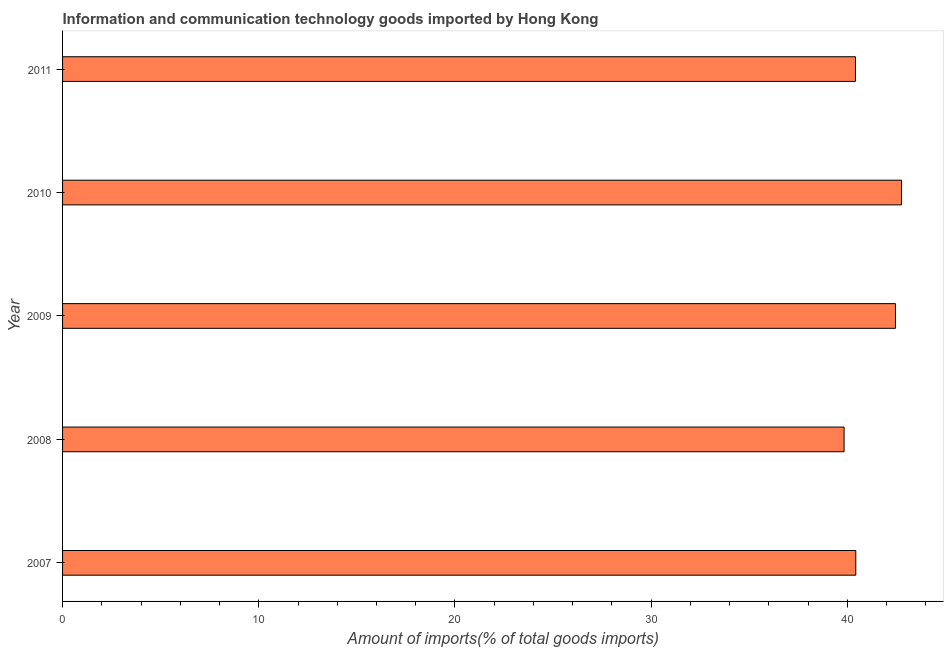Does the graph contain any zero values?
Give a very brief answer. No. What is the title of the graph?
Your answer should be very brief. Information and communication technology goods imported by Hong Kong. What is the label or title of the X-axis?
Your response must be concise. Amount of imports(% of total goods imports). What is the label or title of the Y-axis?
Provide a succinct answer. Year. What is the amount of ict goods imports in 2009?
Provide a short and direct response. 42.45. Across all years, what is the maximum amount of ict goods imports?
Provide a short and direct response. 42.76. Across all years, what is the minimum amount of ict goods imports?
Make the answer very short. 39.83. In which year was the amount of ict goods imports maximum?
Give a very brief answer. 2010. What is the sum of the amount of ict goods imports?
Give a very brief answer. 205.89. What is the difference between the amount of ict goods imports in 2007 and 2009?
Provide a succinct answer. -2.02. What is the average amount of ict goods imports per year?
Provide a short and direct response. 41.18. What is the median amount of ict goods imports?
Provide a short and direct response. 40.43. Is the amount of ict goods imports in 2008 less than that in 2011?
Give a very brief answer. Yes. What is the difference between the highest and the second highest amount of ict goods imports?
Give a very brief answer. 0.31. Is the sum of the amount of ict goods imports in 2007 and 2008 greater than the maximum amount of ict goods imports across all years?
Keep it short and to the point. Yes. What is the difference between the highest and the lowest amount of ict goods imports?
Keep it short and to the point. 2.93. In how many years, is the amount of ict goods imports greater than the average amount of ict goods imports taken over all years?
Your answer should be very brief. 2. How many bars are there?
Your answer should be compact. 5. Are all the bars in the graph horizontal?
Your answer should be very brief. Yes. How many years are there in the graph?
Your response must be concise. 5. What is the difference between two consecutive major ticks on the X-axis?
Your answer should be very brief. 10. Are the values on the major ticks of X-axis written in scientific E-notation?
Your answer should be very brief. No. What is the Amount of imports(% of total goods imports) in 2007?
Give a very brief answer. 40.43. What is the Amount of imports(% of total goods imports) of 2008?
Keep it short and to the point. 39.83. What is the Amount of imports(% of total goods imports) of 2009?
Keep it short and to the point. 42.45. What is the Amount of imports(% of total goods imports) of 2010?
Your answer should be compact. 42.76. What is the Amount of imports(% of total goods imports) in 2011?
Ensure brevity in your answer.  40.41. What is the difference between the Amount of imports(% of total goods imports) in 2007 and 2008?
Your answer should be very brief. 0.6. What is the difference between the Amount of imports(% of total goods imports) in 2007 and 2009?
Your answer should be compact. -2.02. What is the difference between the Amount of imports(% of total goods imports) in 2007 and 2010?
Give a very brief answer. -2.33. What is the difference between the Amount of imports(% of total goods imports) in 2007 and 2011?
Give a very brief answer. 0.02. What is the difference between the Amount of imports(% of total goods imports) in 2008 and 2009?
Keep it short and to the point. -2.62. What is the difference between the Amount of imports(% of total goods imports) in 2008 and 2010?
Ensure brevity in your answer.  -2.93. What is the difference between the Amount of imports(% of total goods imports) in 2008 and 2011?
Make the answer very short. -0.58. What is the difference between the Amount of imports(% of total goods imports) in 2009 and 2010?
Your answer should be compact. -0.31. What is the difference between the Amount of imports(% of total goods imports) in 2009 and 2011?
Your response must be concise. 2.04. What is the difference between the Amount of imports(% of total goods imports) in 2010 and 2011?
Your answer should be compact. 2.35. What is the ratio of the Amount of imports(% of total goods imports) in 2007 to that in 2008?
Make the answer very short. 1.01. What is the ratio of the Amount of imports(% of total goods imports) in 2007 to that in 2009?
Offer a very short reply. 0.95. What is the ratio of the Amount of imports(% of total goods imports) in 2007 to that in 2010?
Your response must be concise. 0.94. What is the ratio of the Amount of imports(% of total goods imports) in 2007 to that in 2011?
Give a very brief answer. 1. What is the ratio of the Amount of imports(% of total goods imports) in 2008 to that in 2009?
Give a very brief answer. 0.94. What is the ratio of the Amount of imports(% of total goods imports) in 2008 to that in 2010?
Your answer should be compact. 0.93. What is the ratio of the Amount of imports(% of total goods imports) in 2009 to that in 2011?
Provide a short and direct response. 1.05. What is the ratio of the Amount of imports(% of total goods imports) in 2010 to that in 2011?
Provide a short and direct response. 1.06. 